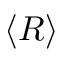Convert formula to latex. <formula><loc_0><loc_0><loc_500><loc_500>\langle R \rangle</formula> 